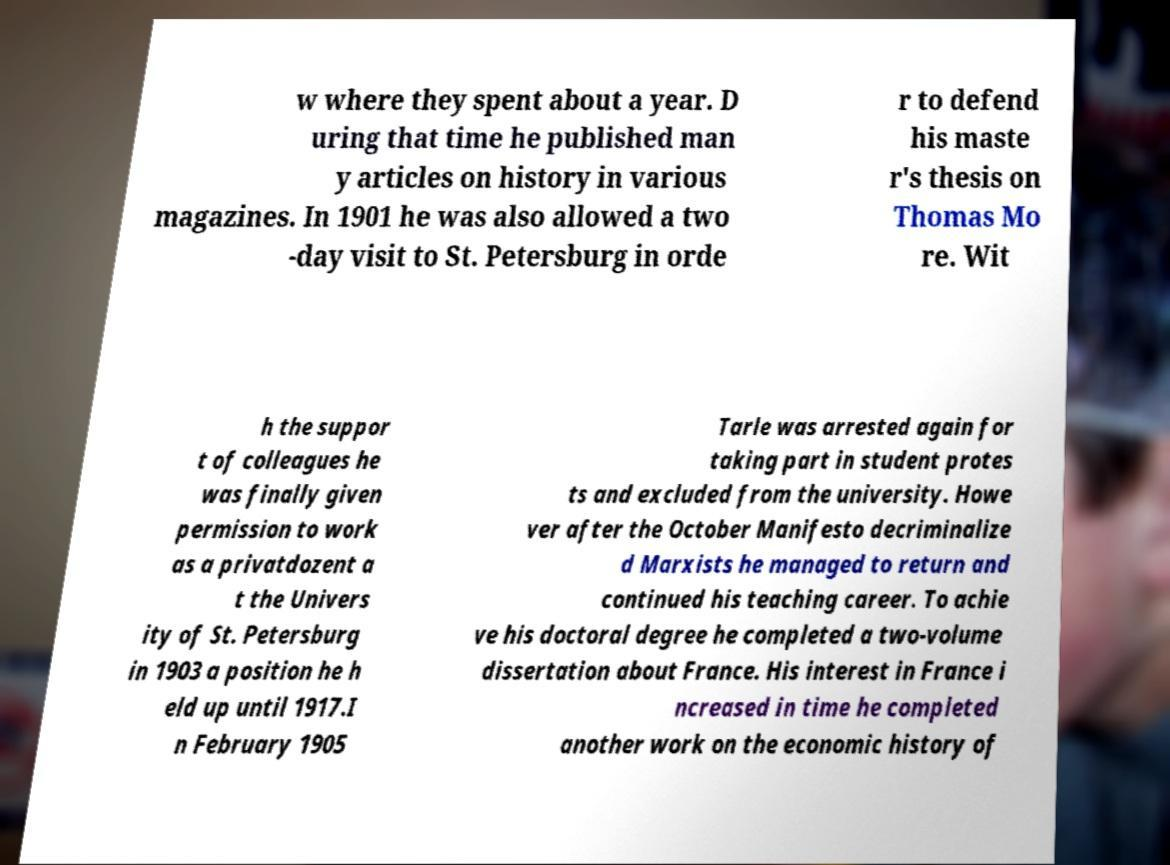Please identify and transcribe the text found in this image. w where they spent about a year. D uring that time he published man y articles on history in various magazines. In 1901 he was also allowed a two -day visit to St. Petersburg in orde r to defend his maste r's thesis on Thomas Mo re. Wit h the suppor t of colleagues he was finally given permission to work as a privatdozent a t the Univers ity of St. Petersburg in 1903 a position he h eld up until 1917.I n February 1905 Tarle was arrested again for taking part in student protes ts and excluded from the university. Howe ver after the October Manifesto decriminalize d Marxists he managed to return and continued his teaching career. To achie ve his doctoral degree he completed a two-volume dissertation about France. His interest in France i ncreased in time he completed another work on the economic history of 